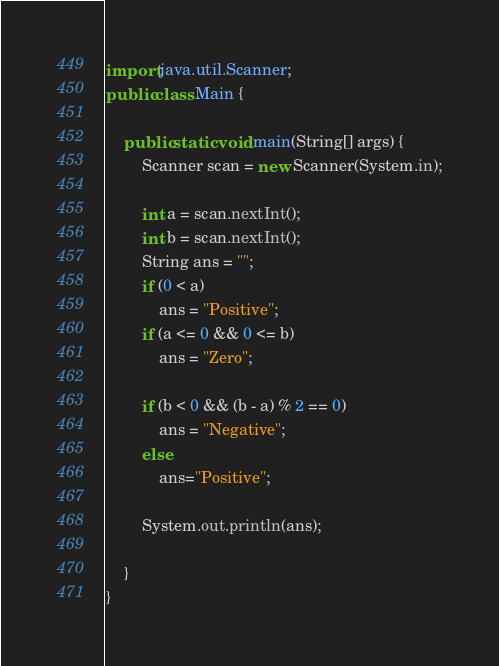Convert code to text. <code><loc_0><loc_0><loc_500><loc_500><_Java_>import java.util.Scanner;
public class Main {

    public static void main(String[] args) {
        Scanner scan = new Scanner(System.in);

        int a = scan.nextInt();
        int b = scan.nextInt();
        String ans = "";
        if (0 < a)
            ans = "Positive";
        if (a <= 0 && 0 <= b)
            ans = "Zero";

        if (b < 0 && (b - a) % 2 == 0)
            ans = "Negative";
        else
            ans="Positive";

        System.out.println(ans);

    }
}</code> 